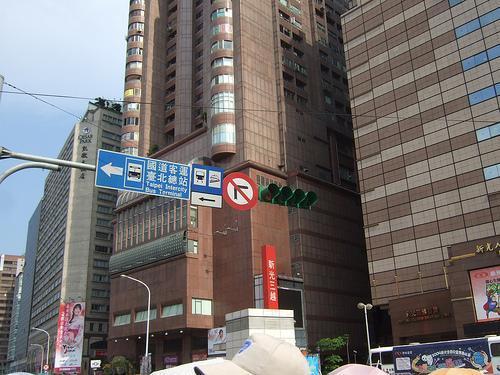How many arrows face left?
Give a very brief answer. 2. 